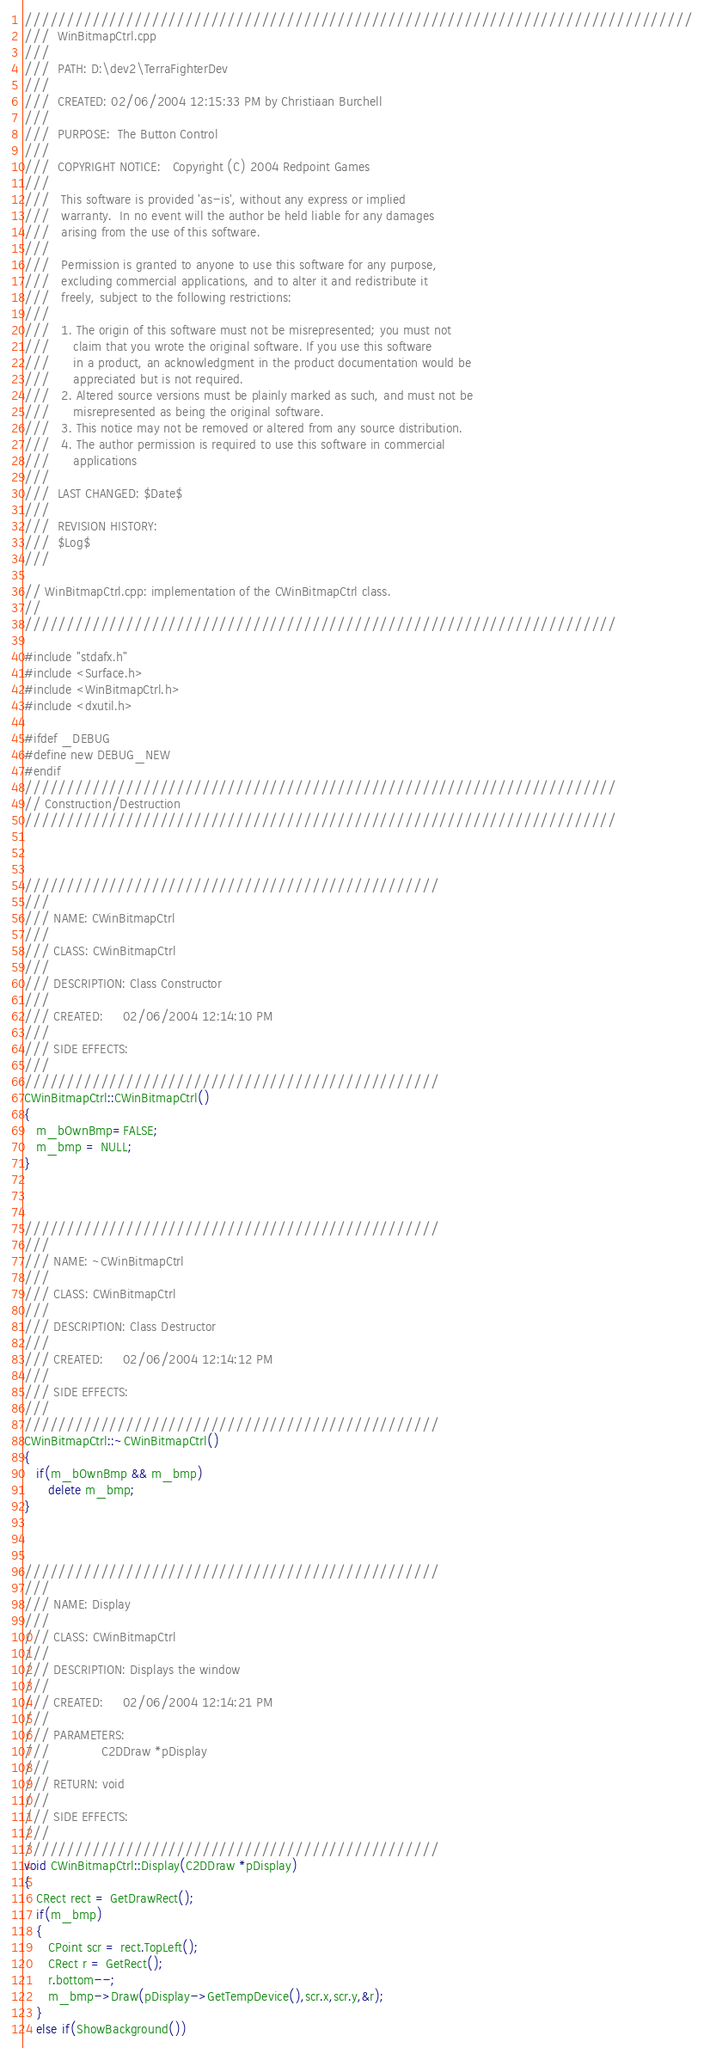Convert code to text. <code><loc_0><loc_0><loc_500><loc_500><_C++_>///////////////////////////////////////////////////////////////////////////////
///  WinBitmapCtrl.cpp
///
///  PATH: D:\dev2\TerraFighterDev
///
///  CREATED: 02/06/2004 12:15:33 PM by Christiaan Burchell
///
///  PURPOSE:  The Button Control
///
///  COPYRIGHT NOTICE:   Copyright (C) 2004 Redpoint Games 
///
///   This software is provided 'as-is', without any express or implied 
///   warranty.  In no event will the author be held liable for any damages 
///   arising from the use of this software. 
/// 
///   Permission is granted to anyone to use this software for any purpose,
///   excluding commercial applications, and to alter it and redistribute it
///   freely, subject to the following restrictions:
/// 
///   1. The origin of this software must not be misrepresented; you must not
///      claim that you wrote the original software. If you use this software
///      in a product, an acknowledgment in the product documentation would be
///      appreciated but is not required.
///   2. Altered source versions must be plainly marked as such, and must not be
///      misrepresented as being the original software.
///   3. This notice may not be removed or altered from any source distribution.
///   4. The author permission is required to use this software in commercial 
///      applications 
///
///  LAST CHANGED: $Date$
///
///  REVISION HISTORY:
///  $Log$
/// 

// WinBitmapCtrl.cpp: implementation of the CWinBitmapCtrl class.
//
//////////////////////////////////////////////////////////////////////

#include "stdafx.h"
#include <Surface.h>
#include <WinBitmapCtrl.h>
#include <dxutil.h>

#ifdef _DEBUG
#define new DEBUG_NEW
#endif
//////////////////////////////////////////////////////////////////////
// Construction/Destruction
//////////////////////////////////////////////////////////////////////



/////////////////////////////////////////////////
///
/// NAME: CWinBitmapCtrl
///
/// CLASS: CWinBitmapCtrl
///
/// DESCRIPTION: Class Constructor
///
/// CREATED:     02/06/2004 12:14:10 PM
///
/// SIDE EFFECTS: 
///
/////////////////////////////////////////////////
CWinBitmapCtrl::CWinBitmapCtrl()
{
   m_bOwnBmp=FALSE;
   m_bmp = NULL;
}



/////////////////////////////////////////////////
///
/// NAME: ~CWinBitmapCtrl
///
/// CLASS: CWinBitmapCtrl
///
/// DESCRIPTION: Class Destructor
///
/// CREATED:     02/06/2004 12:14:12 PM
///
/// SIDE EFFECTS: 
///
/////////////////////////////////////////////////
CWinBitmapCtrl::~CWinBitmapCtrl()
{
   if(m_bOwnBmp && m_bmp)
      delete m_bmp;
}



/////////////////////////////////////////////////
///
/// NAME: Display
///
/// CLASS: CWinBitmapCtrl
///
/// DESCRIPTION: Displays the window
///
/// CREATED:     02/06/2004 12:14:21 PM
///
/// PARAMETERS: 
///             C2DDraw *pDisplay
///
/// RETURN: void 
///
/// SIDE EFFECTS: 
///
/////////////////////////////////////////////////
void CWinBitmapCtrl::Display(C2DDraw *pDisplay)
{
   CRect rect = GetDrawRect();
   if(m_bmp)
   {
      CPoint scr = rect.TopLeft();
      CRect r = GetRect();
      r.bottom--;
      m_bmp->Draw(pDisplay->GetTempDevice(),scr.x,scr.y,&r);
   }
   else if(ShowBackground())</code> 